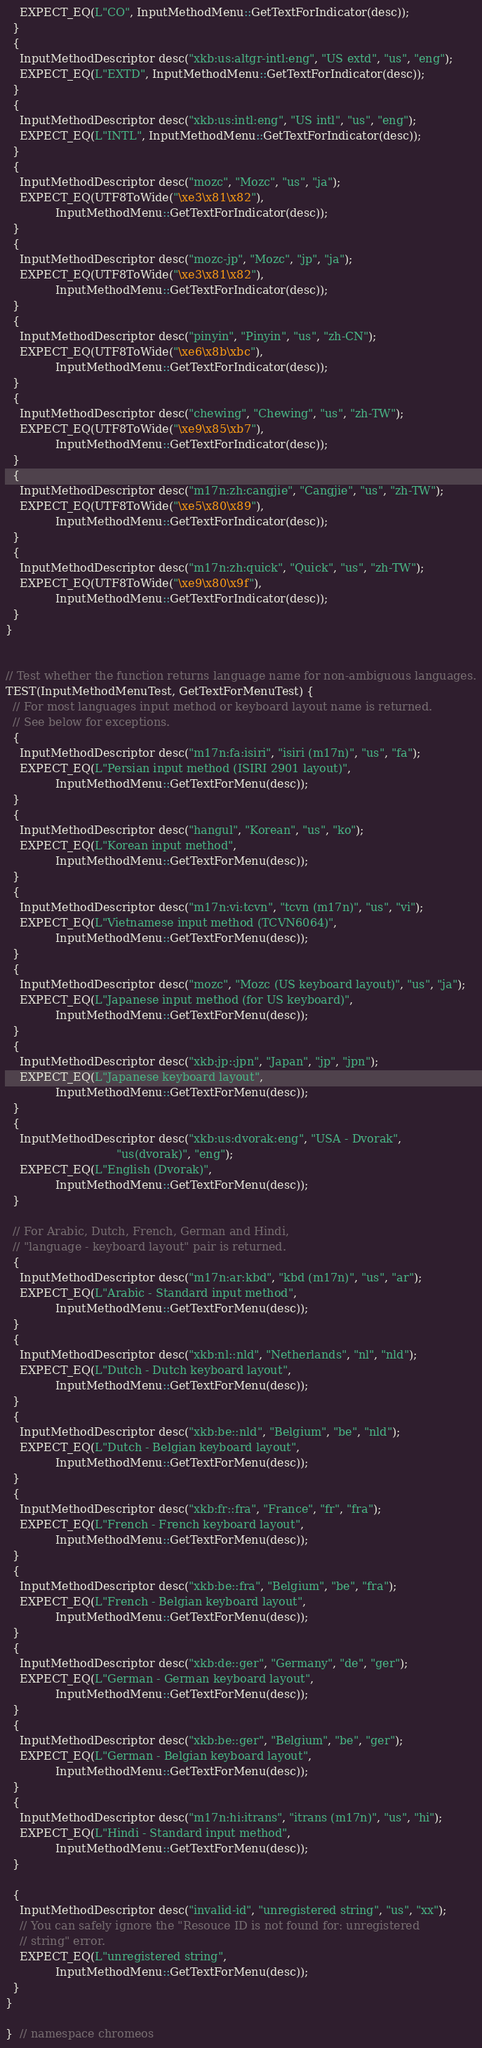<code> <loc_0><loc_0><loc_500><loc_500><_C++_>    EXPECT_EQ(L"CO", InputMethodMenu::GetTextForIndicator(desc));
  }
  {
    InputMethodDescriptor desc("xkb:us:altgr-intl:eng", "US extd", "us", "eng");
    EXPECT_EQ(L"EXTD", InputMethodMenu::GetTextForIndicator(desc));
  }
  {
    InputMethodDescriptor desc("xkb:us:intl:eng", "US intl", "us", "eng");
    EXPECT_EQ(L"INTL", InputMethodMenu::GetTextForIndicator(desc));
  }
  {
    InputMethodDescriptor desc("mozc", "Mozc", "us", "ja");
    EXPECT_EQ(UTF8ToWide("\xe3\x81\x82"),
              InputMethodMenu::GetTextForIndicator(desc));
  }
  {
    InputMethodDescriptor desc("mozc-jp", "Mozc", "jp", "ja");
    EXPECT_EQ(UTF8ToWide("\xe3\x81\x82"),
              InputMethodMenu::GetTextForIndicator(desc));
  }
  {
    InputMethodDescriptor desc("pinyin", "Pinyin", "us", "zh-CN");
    EXPECT_EQ(UTF8ToWide("\xe6\x8b\xbc"),
              InputMethodMenu::GetTextForIndicator(desc));
  }
  {
    InputMethodDescriptor desc("chewing", "Chewing", "us", "zh-TW");
    EXPECT_EQ(UTF8ToWide("\xe9\x85\xb7"),
              InputMethodMenu::GetTextForIndicator(desc));
  }
  {
    InputMethodDescriptor desc("m17n:zh:cangjie", "Cangjie", "us", "zh-TW");
    EXPECT_EQ(UTF8ToWide("\xe5\x80\x89"),
              InputMethodMenu::GetTextForIndicator(desc));
  }
  {
    InputMethodDescriptor desc("m17n:zh:quick", "Quick", "us", "zh-TW");
    EXPECT_EQ(UTF8ToWide("\xe9\x80\x9f"),
              InputMethodMenu::GetTextForIndicator(desc));
  }
}


// Test whether the function returns language name for non-ambiguous languages.
TEST(InputMethodMenuTest, GetTextForMenuTest) {
  // For most languages input method or keyboard layout name is returned.
  // See below for exceptions.
  {
    InputMethodDescriptor desc("m17n:fa:isiri", "isiri (m17n)", "us", "fa");
    EXPECT_EQ(L"Persian input method (ISIRI 2901 layout)",
              InputMethodMenu::GetTextForMenu(desc));
  }
  {
    InputMethodDescriptor desc("hangul", "Korean", "us", "ko");
    EXPECT_EQ(L"Korean input method",
              InputMethodMenu::GetTextForMenu(desc));
  }
  {
    InputMethodDescriptor desc("m17n:vi:tcvn", "tcvn (m17n)", "us", "vi");
    EXPECT_EQ(L"Vietnamese input method (TCVN6064)",
              InputMethodMenu::GetTextForMenu(desc));
  }
  {
    InputMethodDescriptor desc("mozc", "Mozc (US keyboard layout)", "us", "ja");
    EXPECT_EQ(L"Japanese input method (for US keyboard)",
              InputMethodMenu::GetTextForMenu(desc));
  }
  {
    InputMethodDescriptor desc("xkb:jp::jpn", "Japan", "jp", "jpn");
    EXPECT_EQ(L"Japanese keyboard layout",
              InputMethodMenu::GetTextForMenu(desc));
  }
  {
    InputMethodDescriptor desc("xkb:us:dvorak:eng", "USA - Dvorak",
                               "us(dvorak)", "eng");
    EXPECT_EQ(L"English (Dvorak)",
              InputMethodMenu::GetTextForMenu(desc));
  }

  // For Arabic, Dutch, French, German and Hindi,
  // "language - keyboard layout" pair is returned.
  {
    InputMethodDescriptor desc("m17n:ar:kbd", "kbd (m17n)", "us", "ar");
    EXPECT_EQ(L"Arabic - Standard input method",
              InputMethodMenu::GetTextForMenu(desc));
  }
  {
    InputMethodDescriptor desc("xkb:nl::nld", "Netherlands", "nl", "nld");
    EXPECT_EQ(L"Dutch - Dutch keyboard layout",
              InputMethodMenu::GetTextForMenu(desc));
  }
  {
    InputMethodDescriptor desc("xkb:be::nld", "Belgium", "be", "nld");
    EXPECT_EQ(L"Dutch - Belgian keyboard layout",
              InputMethodMenu::GetTextForMenu(desc));
  }
  {
    InputMethodDescriptor desc("xkb:fr::fra", "France", "fr", "fra");
    EXPECT_EQ(L"French - French keyboard layout",
              InputMethodMenu::GetTextForMenu(desc));
  }
  {
    InputMethodDescriptor desc("xkb:be::fra", "Belgium", "be", "fra");
    EXPECT_EQ(L"French - Belgian keyboard layout",
              InputMethodMenu::GetTextForMenu(desc));
  }
  {
    InputMethodDescriptor desc("xkb:de::ger", "Germany", "de", "ger");
    EXPECT_EQ(L"German - German keyboard layout",
              InputMethodMenu::GetTextForMenu(desc));
  }
  {
    InputMethodDescriptor desc("xkb:be::ger", "Belgium", "be", "ger");
    EXPECT_EQ(L"German - Belgian keyboard layout",
              InputMethodMenu::GetTextForMenu(desc));
  }
  {
    InputMethodDescriptor desc("m17n:hi:itrans", "itrans (m17n)", "us", "hi");
    EXPECT_EQ(L"Hindi - Standard input method",
              InputMethodMenu::GetTextForMenu(desc));
  }

  {
    InputMethodDescriptor desc("invalid-id", "unregistered string", "us", "xx");
    // You can safely ignore the "Resouce ID is not found for: unregistered
    // string" error.
    EXPECT_EQ(L"unregistered string",
              InputMethodMenu::GetTextForMenu(desc));
  }
}

}  // namespace chromeos
</code> 